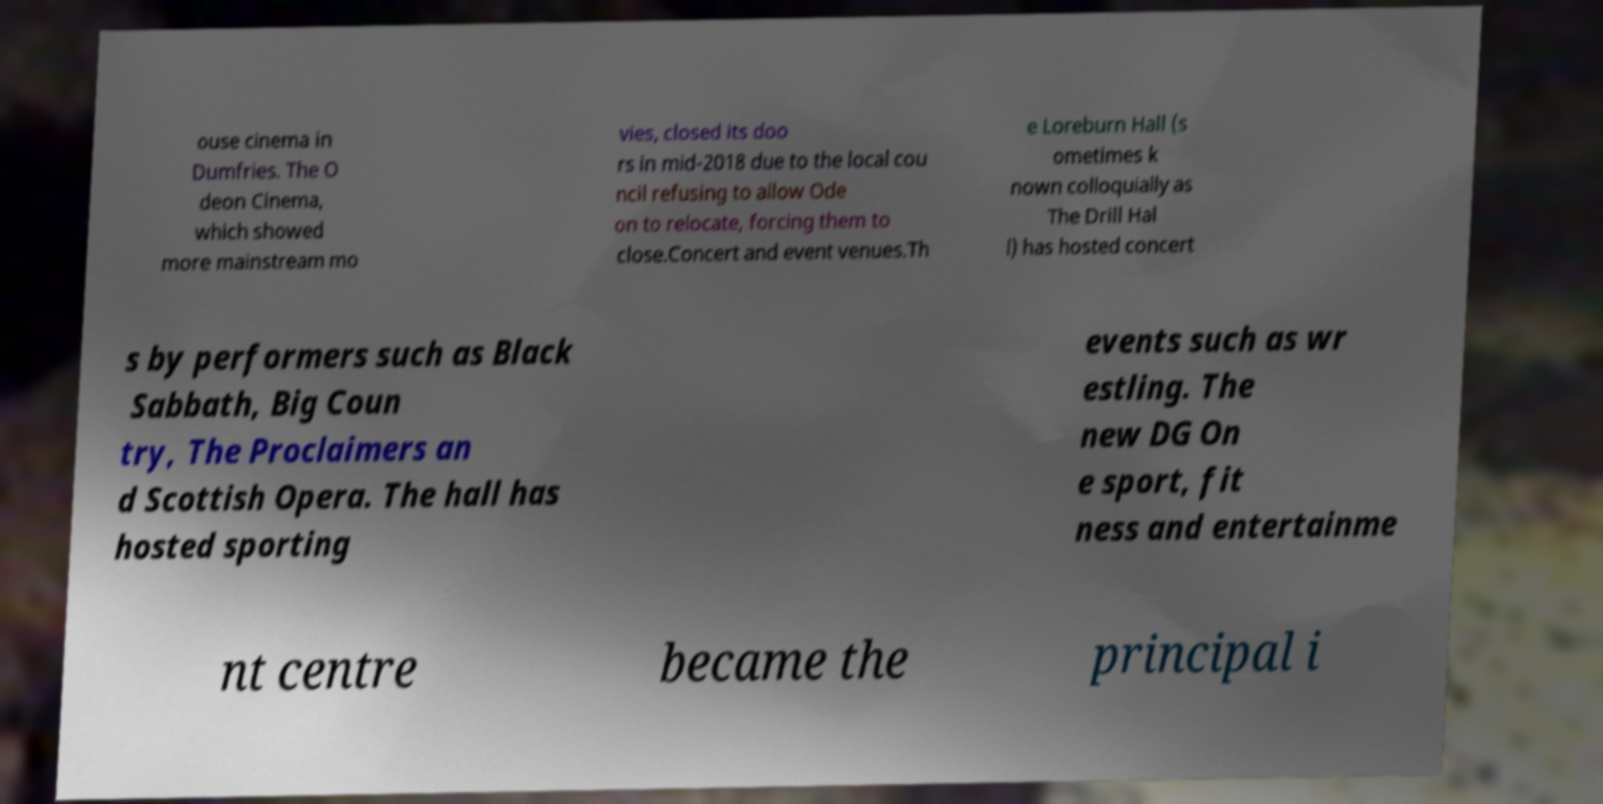Could you extract and type out the text from this image? ouse cinema in Dumfries. The O deon Cinema, which showed more mainstream mo vies, closed its doo rs in mid-2018 due to the local cou ncil refusing to allow Ode on to relocate, forcing them to close.Concert and event venues.Th e Loreburn Hall (s ometimes k nown colloquially as The Drill Hal l) has hosted concert s by performers such as Black Sabbath, Big Coun try, The Proclaimers an d Scottish Opera. The hall has hosted sporting events such as wr estling. The new DG On e sport, fit ness and entertainme nt centre became the principal i 